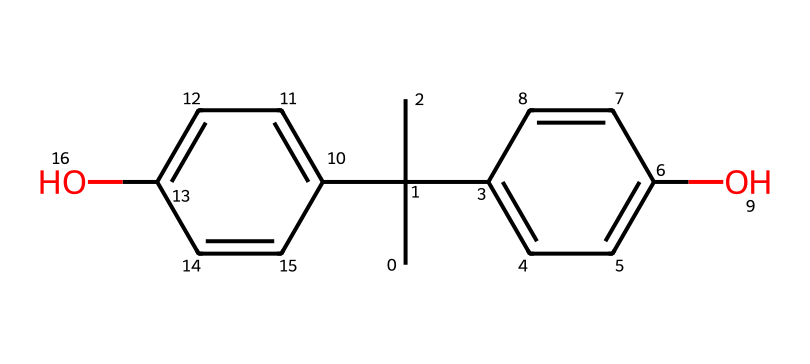What is the molecular formula of BPA? By analyzing the SMILES representation, we can count the atoms. The structure has 15 carbon atoms, 16 hydrogen atoms, and 2 oxygen atoms. This totals to the molecular formula C15H16O2.
Answer: C15H16O2 How many functional groups are present in BPA? In the chemical structure, we can identify two hydroxyl (–OH) groups, which represent the phenolic nature of BPA. Therefore, there are two functional groups.
Answer: 2 What type of bonding is present between the carbon atoms in BPA? The chemical structure demonstrates that the carbon atoms are connected by single and double bonds; specifically, the presence of the ‘C=C’ double bonds indicates unsaturation.
Answer: single and double bonds What type of aromatic systems are present in BPA? The structure reveals two phenolic moieties (aromatic rings), signifying that BPA has two aromatic systems which contribute to its stability and reactivity.
Answer: two aromatic systems What feature contributes to BPA’s potential estrogen-like activity? The presence of hydroxyl (–OH) groups on the aromatic rings allows BPA to interact with estrogen receptors in living organisms, giving it estrogen-like activity.
Answer: hydroxyl groups What indicates that BPA is a synthetic compound? The molecular structure shows that BPA is composed of thiol functional groups and a complex arrangement of carbon, indicating it is not a naturally occurring compound, thus confirming its synthetic nature.
Answer: synthetic compound How many rings are present in the BPA structure? Upon closely inspecting the SMILES representation, we can observe two aromatic rings making up the compound’s structure, confirming the presence of two rings in BPA.
Answer: 2 rings 